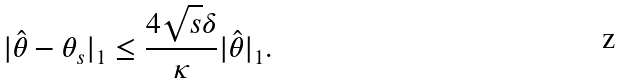Convert formula to latex. <formula><loc_0><loc_0><loc_500><loc_500>| \hat { \theta } - \theta _ { s } | _ { 1 } \leq \frac { 4 \sqrt { s } \delta } { \kappa } | \hat { \theta } | _ { 1 } .</formula> 